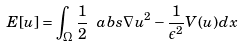<formula> <loc_0><loc_0><loc_500><loc_500>E [ u ] = \int _ { \Omega } \frac { 1 } { 2 } \ a b s { \nabla u } ^ { 2 } - \frac { 1 } { \epsilon ^ { 2 } } V ( u ) d x</formula> 